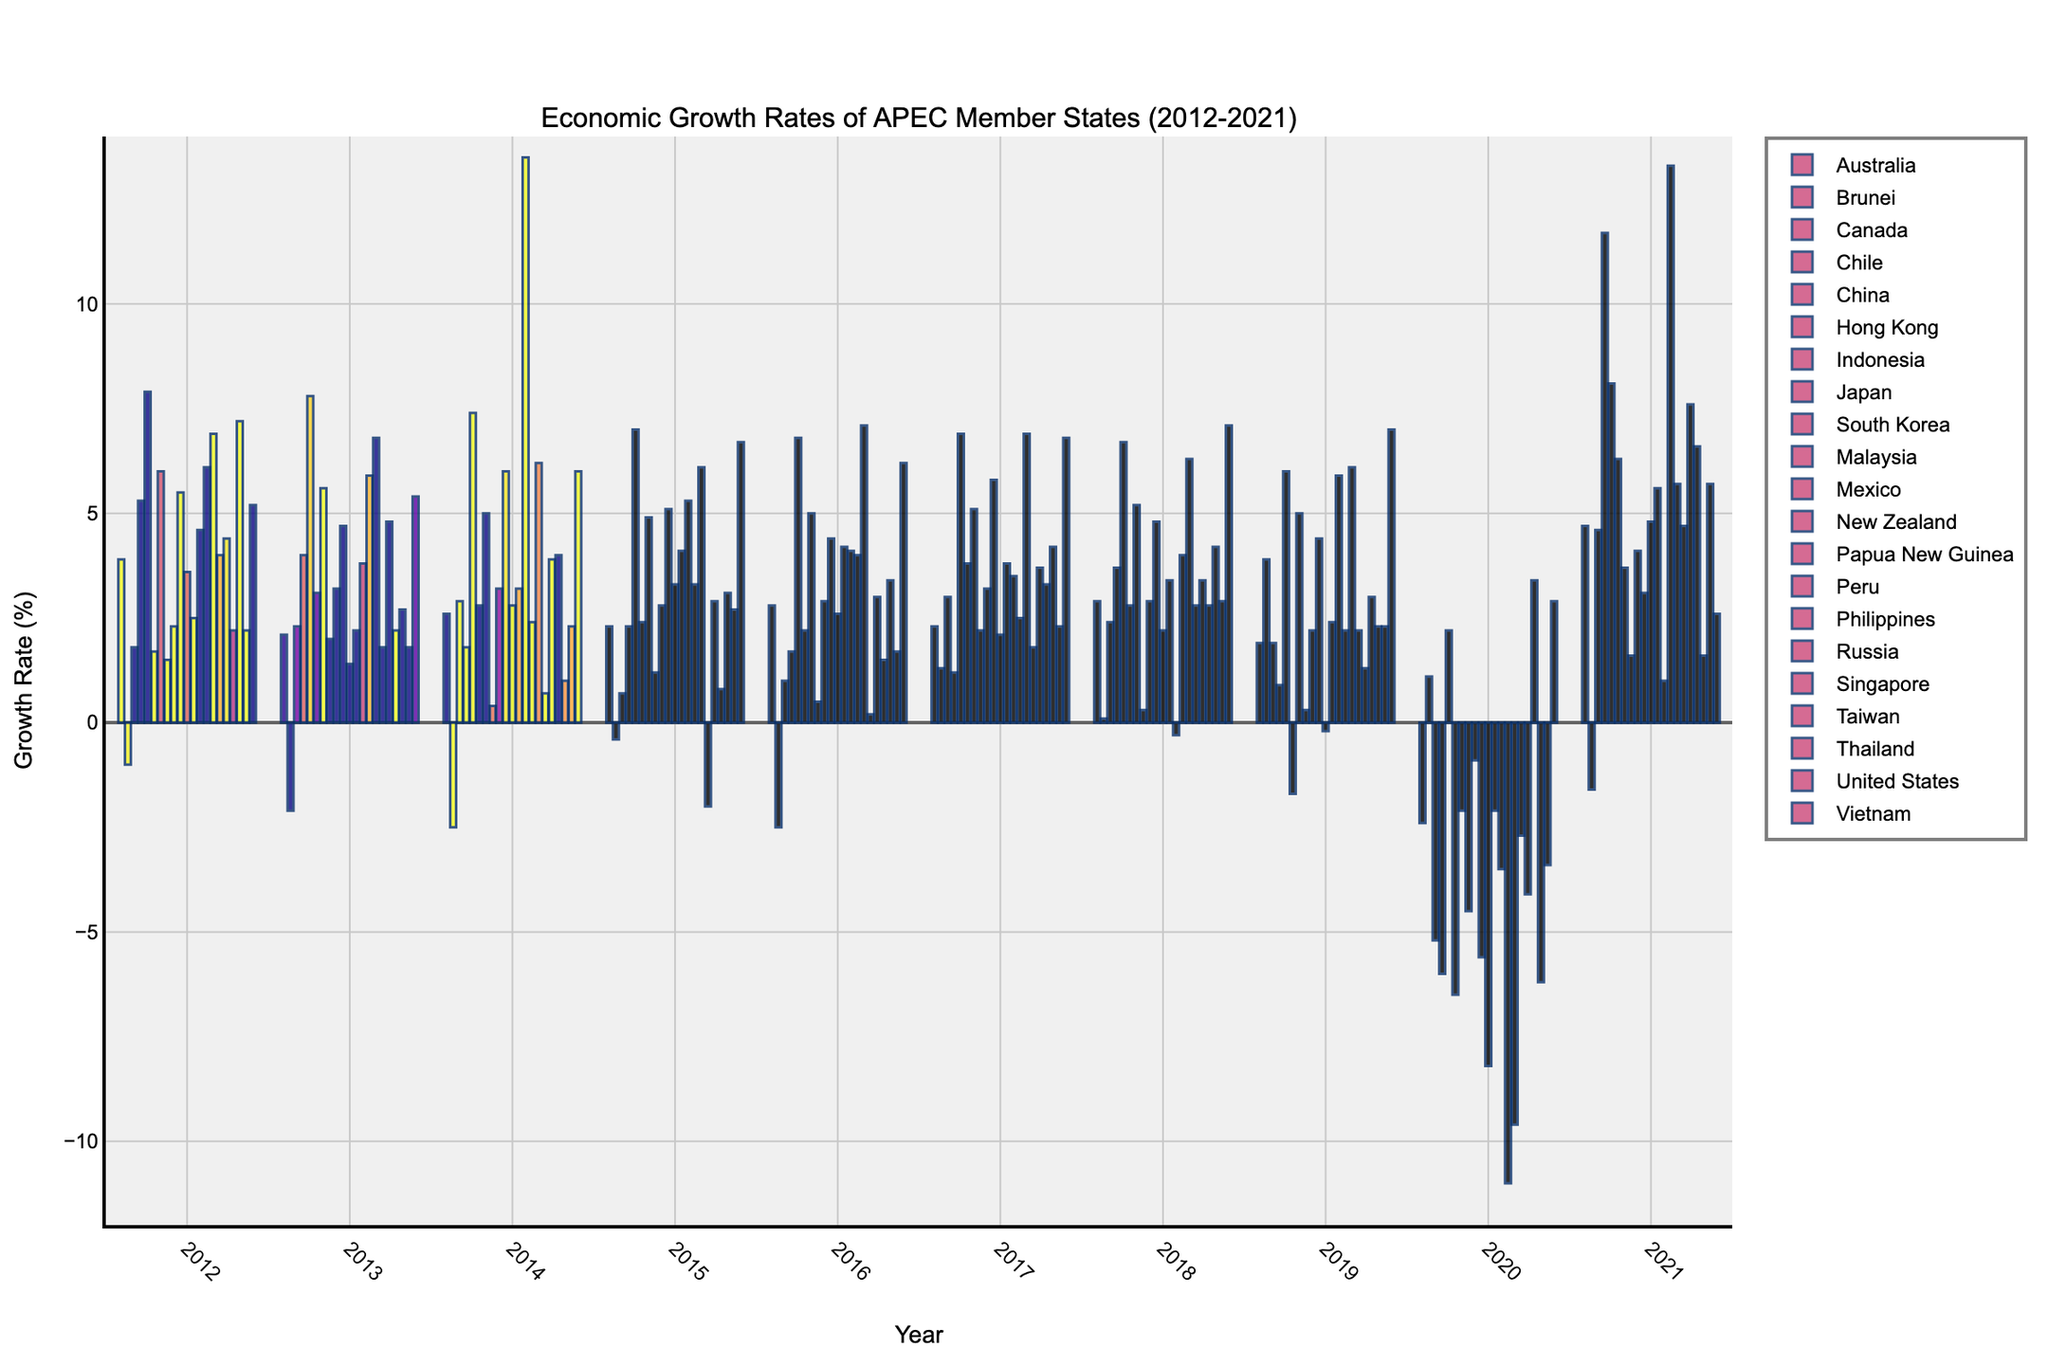What's the average economic growth rate of China over the 10 years? Summing the growth rates: (7.9 + 7.8 + 7.4 + 7.0 + 6.8 + 6.9 + 6.7 + 6.0 + 2.2 + 8.1) = 66.8. Then, dividing by 10, the average is 66.8 / 10 = 6.68
Answer: 6.68 Which country had the highest economic growth rate in 2014? Identify the highest value in the 2014 column. Papua New Guinea had the highest rate with 13.5%
Answer: Papua New Guinea What is the difference in economic growth rate between Vietnam and Malaysia in 2018? Vietnam's growth rate in 2018 is 7.1%, and Malaysia's is 4.8%. The difference is 7.1% - 4.8% = 2.3%
Answer: 2.3% In which year did the United States experience its lowest economic growth rate? By scanning the United States growth rates, the lowest is -3.4% in 2020
Answer: 2020 Which country had the most significant drop in economic growth rate from 2019 to 2020? By examining the differences for each country between 2019 and 2020, Peru showed the most significant drop from 2.2% to -11.0%, which is a difference of 13.2%
Answer: Peru What is the median economic growth rate of South Korea over the 10 years? Ordering the growth rates: -0.9, 2.2, 2.3, 2.8, 2.9, 2.9, 3.2, 3.2, 3.2, 4.1. The middle two values are 2.9, and 2.9. The median is (2.9 + 2.9) / 2 = 2.9
Answer: 2.9 Which country's economic growth rate remained positive every year? Scanning each country's data, Vietnam's growth rates are positive every year from 2012 to 2021
Answer: Vietnam Which country had the most consistent economic growth rate, showing the least fluctuation over the decade? China shows the least fluctuation in its growth rates, staying within a range from 2.2% to 8.1%, and most years close to 7%
Answer: China Between 2012 and 2021, how many times did Peru experience negative economic growth rates? Peru had negative growth rates in 2020 with -11.0%, so it experienced a negative rate 1 time
Answer: 1 